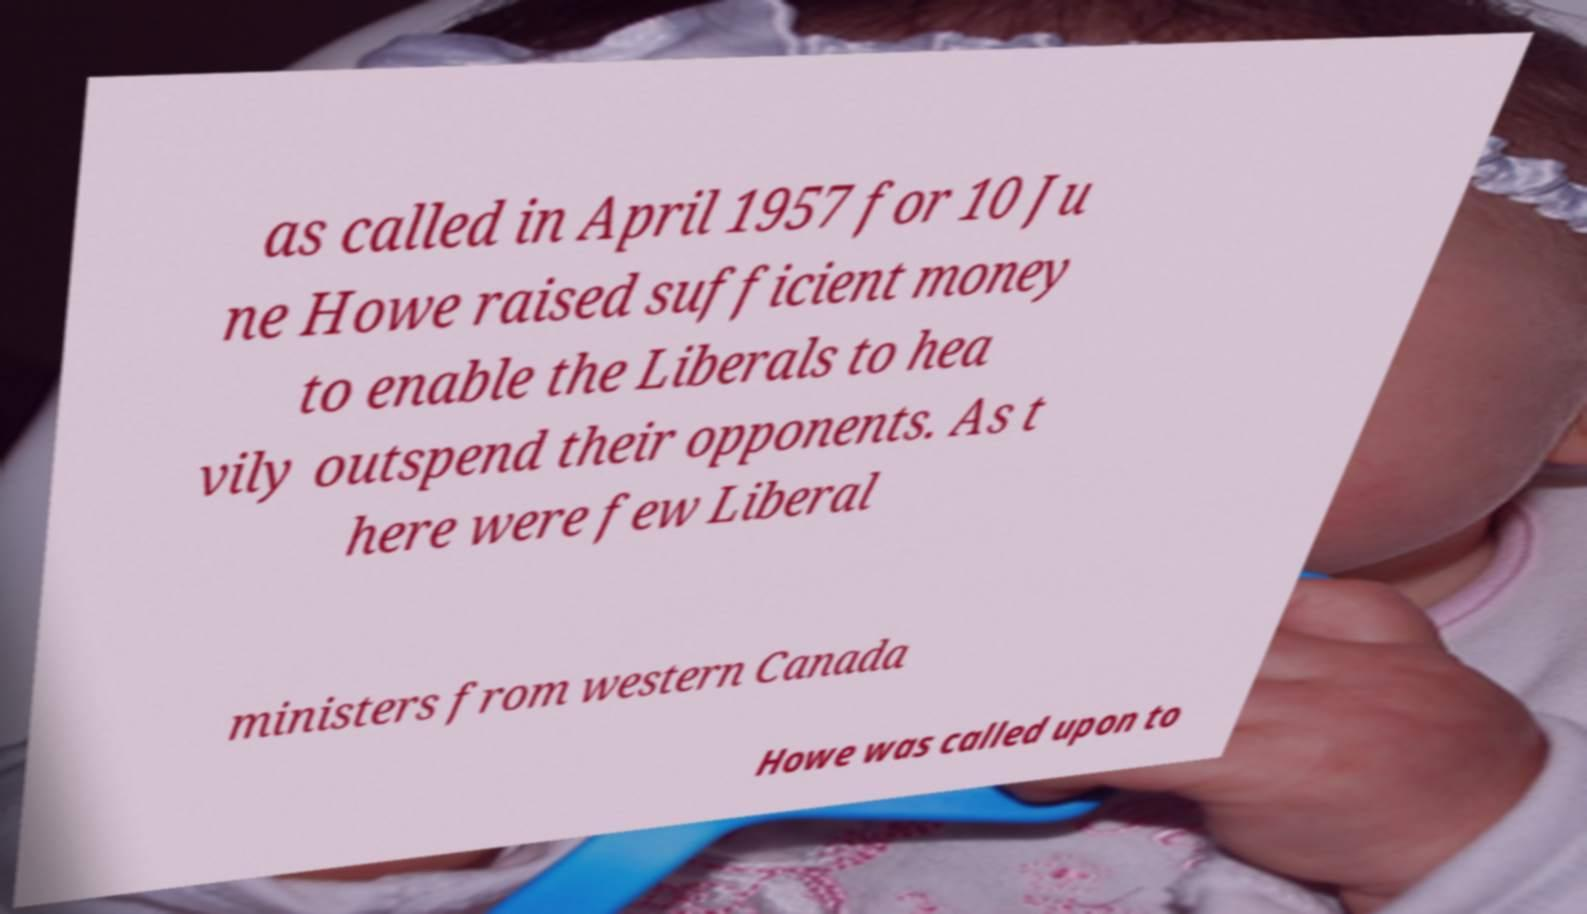Could you assist in decoding the text presented in this image and type it out clearly? as called in April 1957 for 10 Ju ne Howe raised sufficient money to enable the Liberals to hea vily outspend their opponents. As t here were few Liberal ministers from western Canada Howe was called upon to 